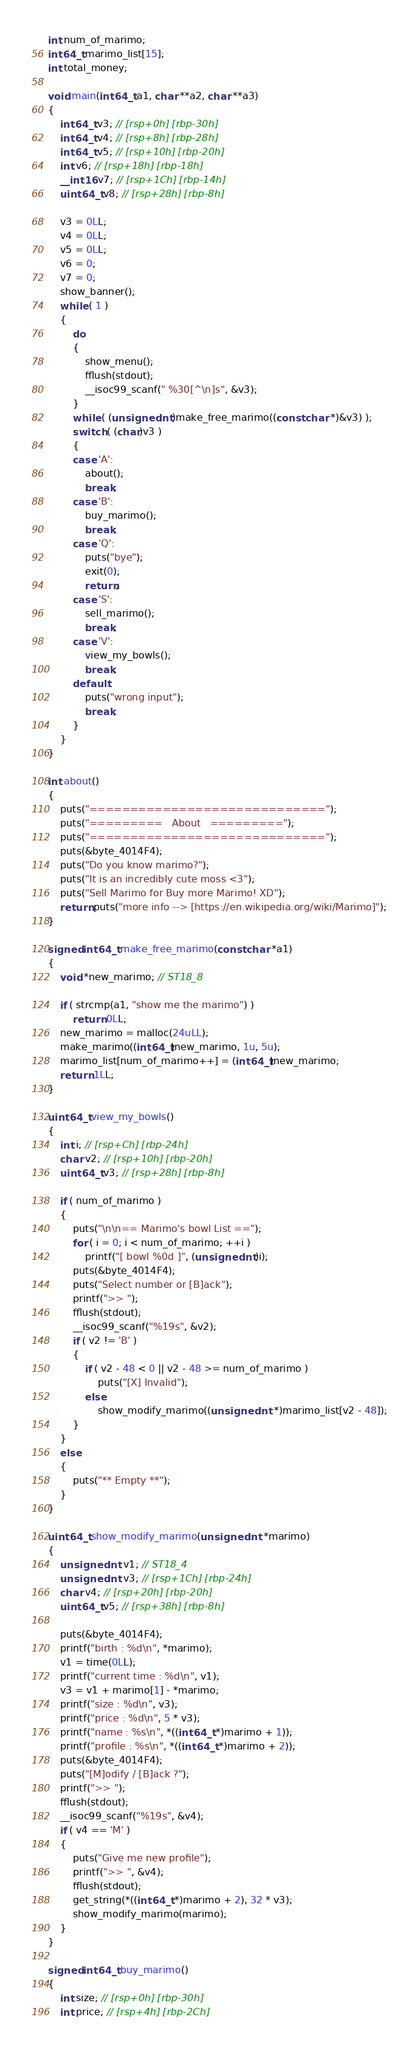<code> <loc_0><loc_0><loc_500><loc_500><_C++_>int num_of_marimo;
int64_t marimo_list[15];
int total_money;

void main(int64_t a1, char **a2, char **a3)
{
    int64_t v3; // [rsp+0h] [rbp-30h]
    int64_t v4; // [rsp+8h] [rbp-28h]
    int64_t v5; // [rsp+10h] [rbp-20h]
    int v6; // [rsp+18h] [rbp-18h]
    __int16 v7; // [rsp+1Ch] [rbp-14h]
    uint64_t v8; // [rsp+28h] [rbp-8h]

    v3 = 0LL;
    v4 = 0LL;
    v5 = 0LL;
    v6 = 0;
    v7 = 0;
    show_banner();
    while ( 1 )
    {
        do
        {
            show_menu();
            fflush(stdout);
            __isoc99_scanf(" %30[^\n]s", &v3);
        }
        while ( (unsigned int)make_free_marimo((const char *)&v3) );
        switch ( (char)v3 )
        {
        case 'A':
            about();
            break;
        case 'B':
            buy_marimo();
            break;
        case 'Q':
            puts("bye");
            exit(0);
            return;
        case 'S':
            sell_marimo();
            break;
        case 'V':
            view_my_bowls();
            break;
        default:
            puts("wrong input");
            break;
        }
    }
}

int about()
{
    puts("=============================");
    puts("=========   About   =========");
    puts("=============================");
    puts(&byte_4014F4);
    puts("Do you know marimo?");
    puts("It is an incredibly cute moss <3");
    puts("Sell Marimo for Buy more Marimo! XD");
    return puts("more info --> [https://en.wikipedia.org/wiki/Marimo]");
}

signed int64_t make_free_marimo(const char *a1)
{
    void *new_marimo; // ST18_8

    if ( strcmp(a1, "show me the marimo") )
        return 0LL;
    new_marimo = malloc(24uLL);
    make_marimo((int64_t)new_marimo, 1u, 5u);
    marimo_list[num_of_marimo++] = (int64_t)new_marimo;
    return 1LL;
}

uint64_t view_my_bowls()
{
    int i; // [rsp+Ch] [rbp-24h]
    char v2; // [rsp+10h] [rbp-20h]
    uint64_t v3; // [rsp+28h] [rbp-8h]

    if ( num_of_marimo )
    {
        puts("\n\n== Marimo's bowl List ==");
        for ( i = 0; i < num_of_marimo; ++i )
            printf("[ bowl %0d ]", (unsigned int)i);
        puts(&byte_4014F4);
        puts("Select number or [B]ack");
        printf(">> ");
        fflush(stdout);
        __isoc99_scanf("%19s", &v2);
        if ( v2 != 'B' )
        {
            if ( v2 - 48 < 0 || v2 - 48 >= num_of_marimo )
                puts("[X] Invalid");
            else
                show_modify_marimo((unsigned int *)marimo_list[v2 - 48]);
        }
    }
    else
    {
        puts("** Empty **");
    }
}

uint64_t show_modify_marimo(unsigned int *marimo)
{
    unsigned int v1; // ST18_4
    unsigned int v3; // [rsp+1Ch] [rbp-24h]
    char v4; // [rsp+20h] [rbp-20h]
    uint64_t v5; // [rsp+38h] [rbp-8h]

    puts(&byte_4014F4);
    printf("birth : %d\n", *marimo);
    v1 = time(0LL);
    printf("current time : %d\n", v1);
    v3 = v1 + marimo[1] - *marimo;
    printf("size : %d\n", v3);
    printf("price : %d\n", 5 * v3);
    printf("name : %s\n", *((int64_t *)marimo + 1));
    printf("profile : %s\n", *((int64_t *)marimo + 2));
    puts(&byte_4014F4);
    puts("[M]odify / [B]ack ?");
    printf(">> ");
    fflush(stdout);
    __isoc99_scanf("%19s", &v4);
    if ( v4 == 'M' )
    {
        puts("Give me new profile");
        printf(">> ", &v4);
        fflush(stdout);
        get_string(*((int64_t *)marimo + 2), 32 * v3);
        show_modify_marimo(marimo);
    }
}

signed int64_t buy_marimo()
{
    int size; // [rsp+0h] [rbp-30h]
    int price; // [rsp+4h] [rbp-2Ch]</code> 